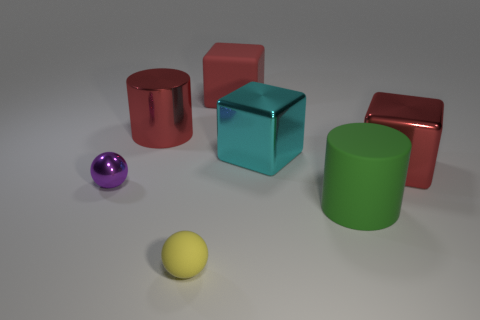Subtract all metallic cubes. How many cubes are left? 1 Add 2 tiny spheres. How many objects exist? 9 Subtract all cyan cubes. How many cubes are left? 2 Subtract 2 blocks. How many blocks are left? 1 Add 5 large red metal blocks. How many large red metal blocks exist? 6 Subtract 0 brown cylinders. How many objects are left? 7 Subtract all spheres. How many objects are left? 5 Subtract all green cubes. Subtract all blue cylinders. How many cubes are left? 3 Subtract all cyan cylinders. How many red cubes are left? 2 Subtract all yellow shiny things. Subtract all big red metallic blocks. How many objects are left? 6 